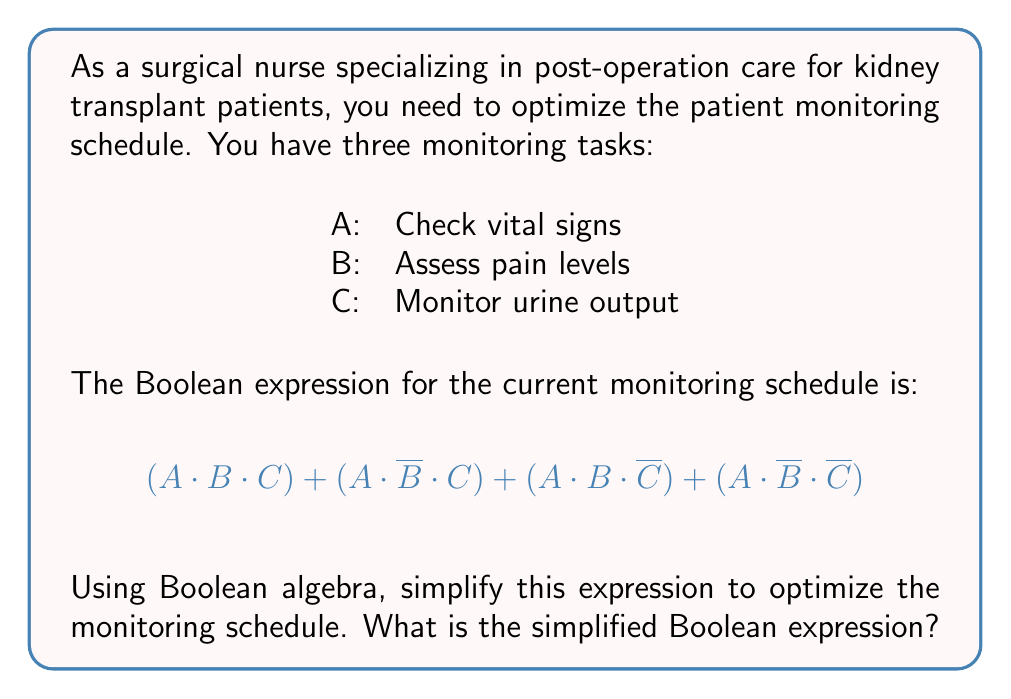Provide a solution to this math problem. Let's simplify the given Boolean expression step by step:

1) First, we can factor out A from all terms:
   $A \cdot [(B \cdot C) + (\overline{B} \cdot C) + (B \cdot \overline{C}) + (\overline{B} \cdot \overline{C})]$

2) Inside the brackets, we can group terms with C and terms with $\overline{C}$:
   $A \cdot [C \cdot (B + \overline{B}) + \overline{C} \cdot (B + \overline{B})]$

3) $(B + \overline{B})$ is always true (1) in Boolean algebra:
   $A \cdot [C \cdot 1 + \overline{C} \cdot 1]$

4) Simplify:
   $A \cdot (C + \overline{C})$

5) $(C + \overline{C})$ is always true (1) in Boolean algebra:
   $A \cdot 1$

6) Final simplification:
   $A$

This means that the only essential task in the monitoring schedule is checking vital signs (A). The other tasks (B and C) do not affect the overall schedule according to this Boolean expression.
Answer: $A$ 